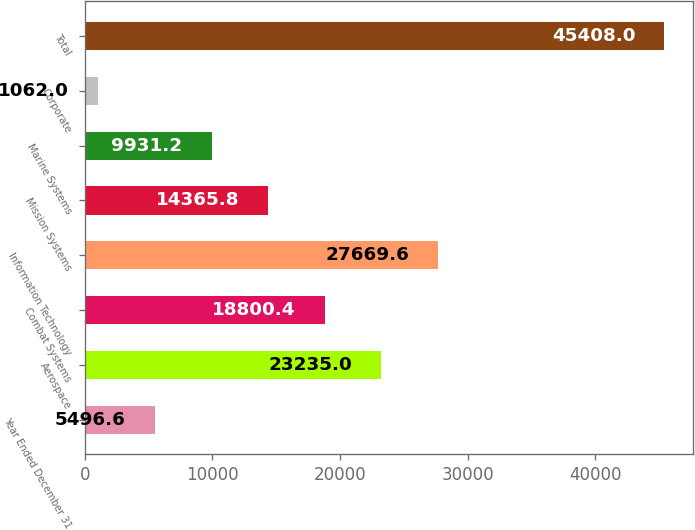Convert chart. <chart><loc_0><loc_0><loc_500><loc_500><bar_chart><fcel>Year Ended December 31<fcel>Aerospace<fcel>Combat Systems<fcel>Information Technology<fcel>Mission Systems<fcel>Marine Systems<fcel>Corporate<fcel>Total<nl><fcel>5496.6<fcel>23235<fcel>18800.4<fcel>27669.6<fcel>14365.8<fcel>9931.2<fcel>1062<fcel>45408<nl></chart> 